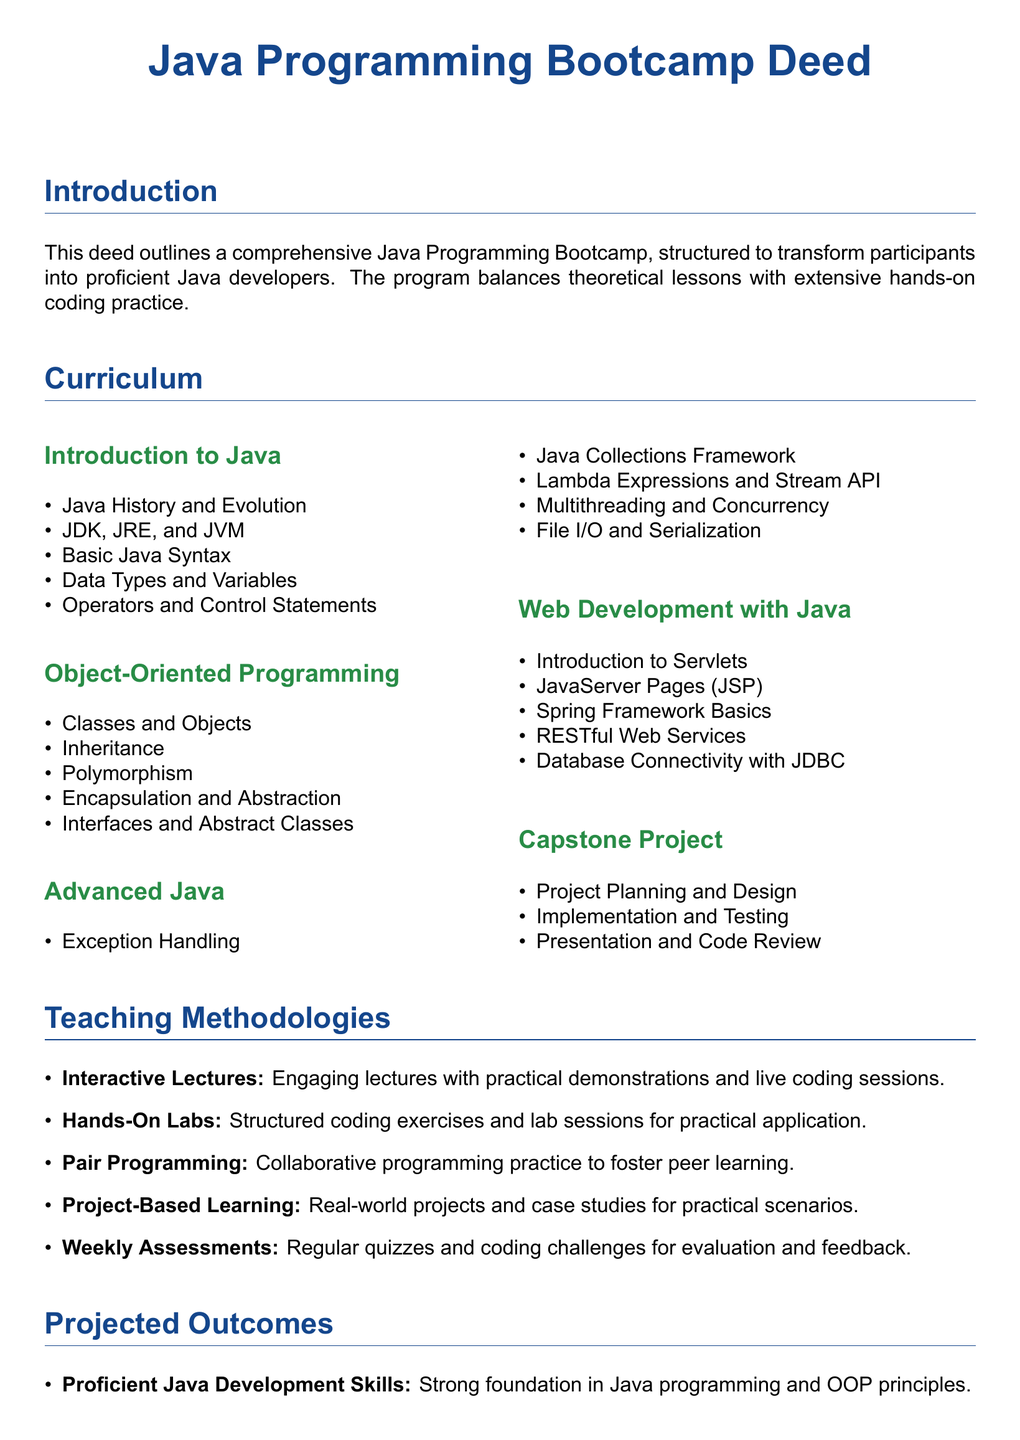What is the title of the document? The title of the document identified in the center is the main heading that describes the subject.
Answer: Java Programming Bootcamp Deed How many major sections are in the curriculum? The document lists curriculum components in distinct subsections, which can be counted for the total.
Answer: 5 What is the first topic covered in the 'Object-Oriented Programming' section? The first item listed in the Object-Oriented Programming section indicates the primary concept taught.
Answer: Classes and Objects Which teaching methodology involves collaborative programming? The teaching methodologies section specifies types of advanced learning practices utilized in the program.
Answer: Pair Programming What is the projected career outcome for participants? The projected outcomes section summarizes the ultimate goal for attendees regarding their professional readiness.
Answer: Career Readiness Which technology is introduced for web development? The web development curriculum mentions key frameworks or technologies involved in the course.
Answer: Spring Framework Basics What type of learning is emphasized by having regular quizzes and coding challenges? The document highlights a certain method for continuous assessment and feedback in the teaching process.
Answer: Weekly Assessments What is the last step in the Capstone Project? The last task in the capstone project phase illustrates the concluding activity of the program.
Answer: Presentation and Code Review What is the color theme of the document? The color definitions provided in the document detail the distinct hues employed for sections.
Answer: Java blue and Java green 